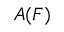<formula> <loc_0><loc_0><loc_500><loc_500>A ( F )</formula> 